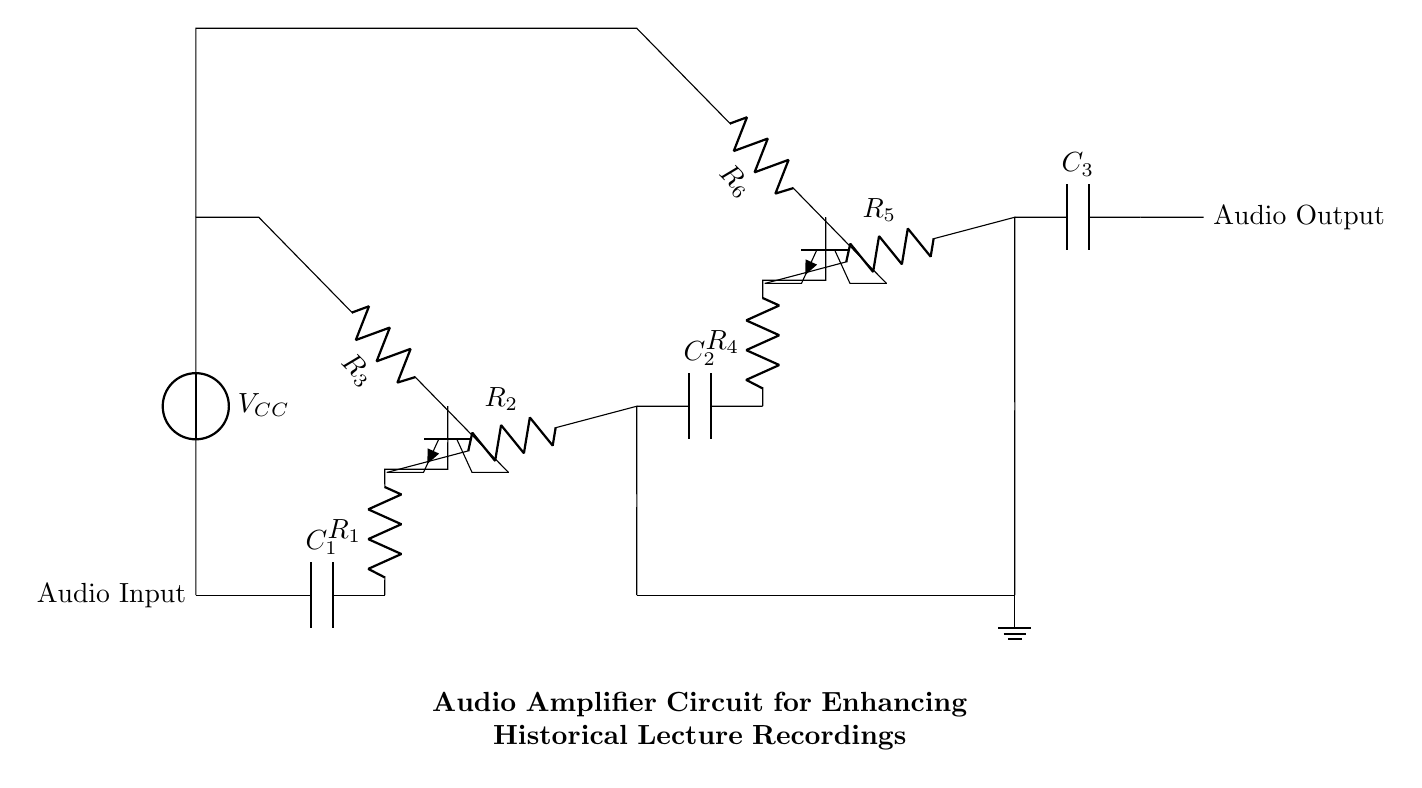What is the purpose of C1? C1 is a coupling capacitor that allows alternating current signals to pass while blocking direct current. This helps to isolate different stages of the amplifier from each other.
Answer: Coupling capacitor What type of transistors are used in the circuit? The circuit uses NPN transistors, which are indicated by the symbol shown next to the label Q1 and Q2. NPN transistors are commonly used in amplifier circuits to enhance the audio signal.
Answer: NPN What is the main function of R1? R1 is a resistor that helps to control the current flowing into the first stage amplifier, which affects the gain of the amplifier circuit. It plays a crucial role in determining how much amplification the audio signal will receive.
Answer: Control current How many stages of amplification are present in this circuit? The circuit has two stages of amplification, as indicated by the two sets of transistor and resistor components (Q1 and Q2) that work to increase the strength of the audio signal.
Answer: Two stages What is the role of C2 in the circuit? C2 is another coupling capacitor that allows the amplified audio signal to pass to the second stage while blocking any DC component, ensuring that only the desired audio frequency signal reaches the next stage.
Answer: Coupling capacitor What is the function of the voltage source labeled VCC? VCC provides the necessary biasing voltage for the transistors in the circuit, ensuring that they operate in the correct region of their characteristic curves, which is essential for effective amplification.
Answer: Biasing voltage Which component connects the circuit to the ground? The ground is connected via a short to the point indicated by the ground symbol, specifically at the junction connecting R2 and R5 to the common ground reference point in the circuit.
Answer: Ground connection 